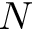<formula> <loc_0><loc_0><loc_500><loc_500>N</formula> 